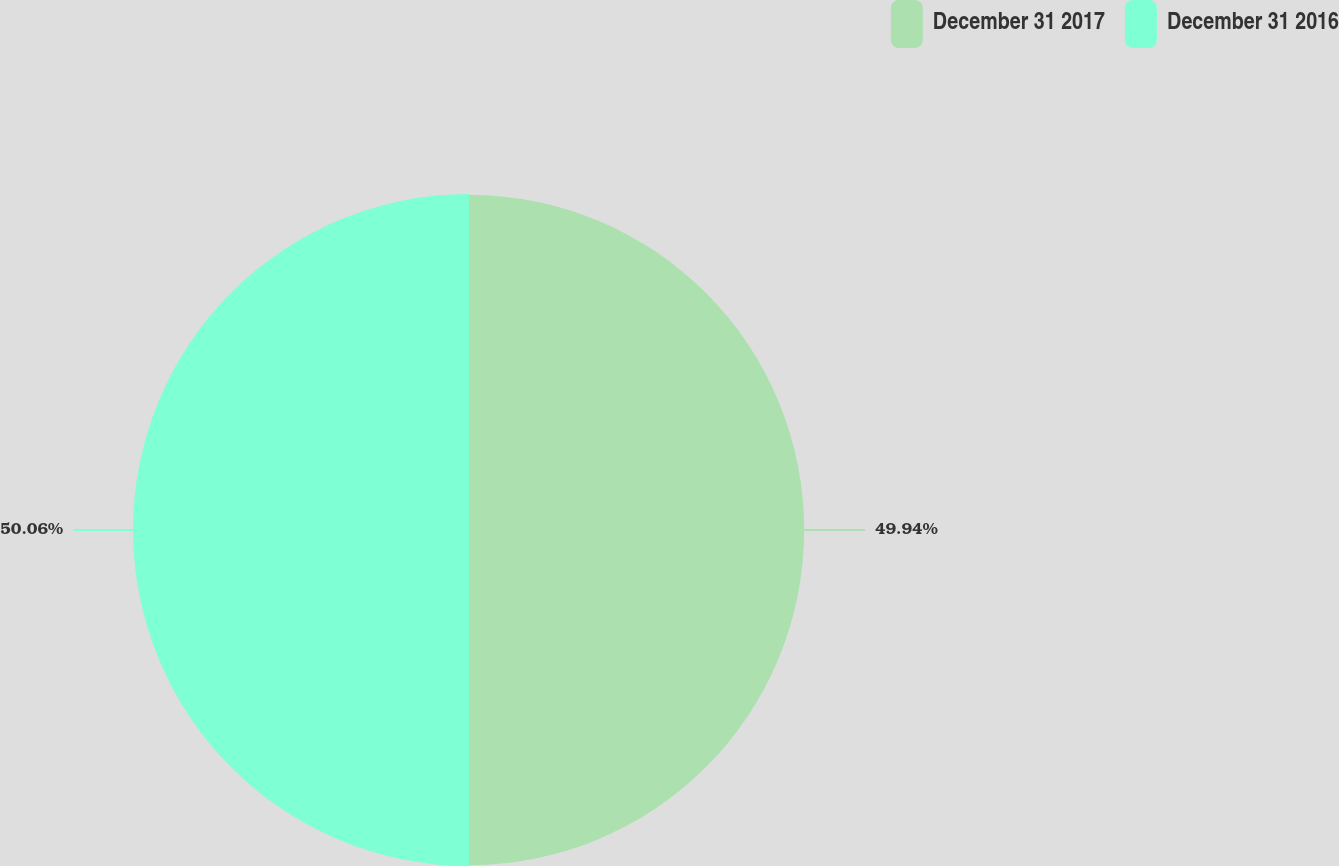<chart> <loc_0><loc_0><loc_500><loc_500><pie_chart><fcel>December 31 2017<fcel>December 31 2016<nl><fcel>49.94%<fcel>50.06%<nl></chart> 